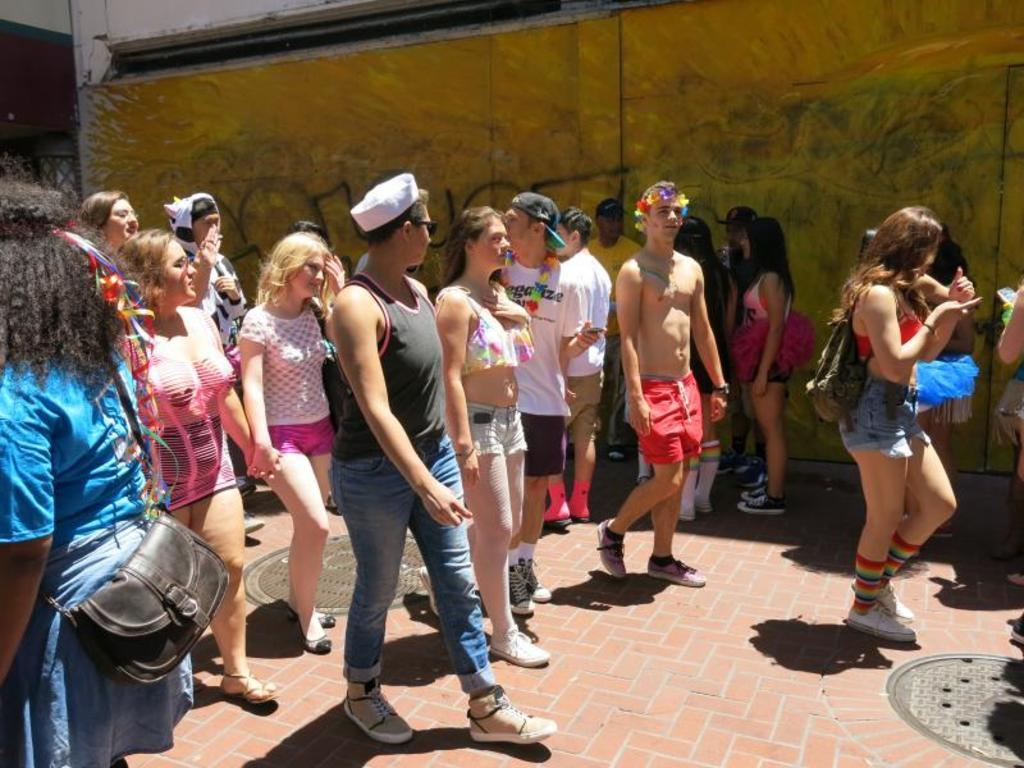What are the people in the image wearing? The persons in the image are wearing clothes. What can be seen on the ground in the image? There are manholes on the ground in the image. What is visible in the background of the image? There is a wall visible in the background of the image. How many frogs are sitting on the wall in the image? There are no frogs present in the image; only persons, manholes, and a wall are visible. 